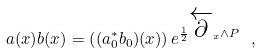<formula> <loc_0><loc_0><loc_500><loc_500>a ( x ) b ( x ) = \left ( ( a _ { 0 } ^ { * } b _ { 0 } ) ( x ) \right ) e ^ { \frac { 1 } { 2 } \overleftarrow { \partial } _ { x } \wedge { P } } \ ,</formula> 